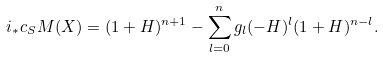Convert formula to latex. <formula><loc_0><loc_0><loc_500><loc_500>i _ { * } c _ { S } M ( X ) = ( 1 + H ) ^ { n + 1 } - \sum _ { l = 0 } ^ { n } g _ { l } ( - H ) ^ { l } ( 1 + H ) ^ { n - l } .</formula> 